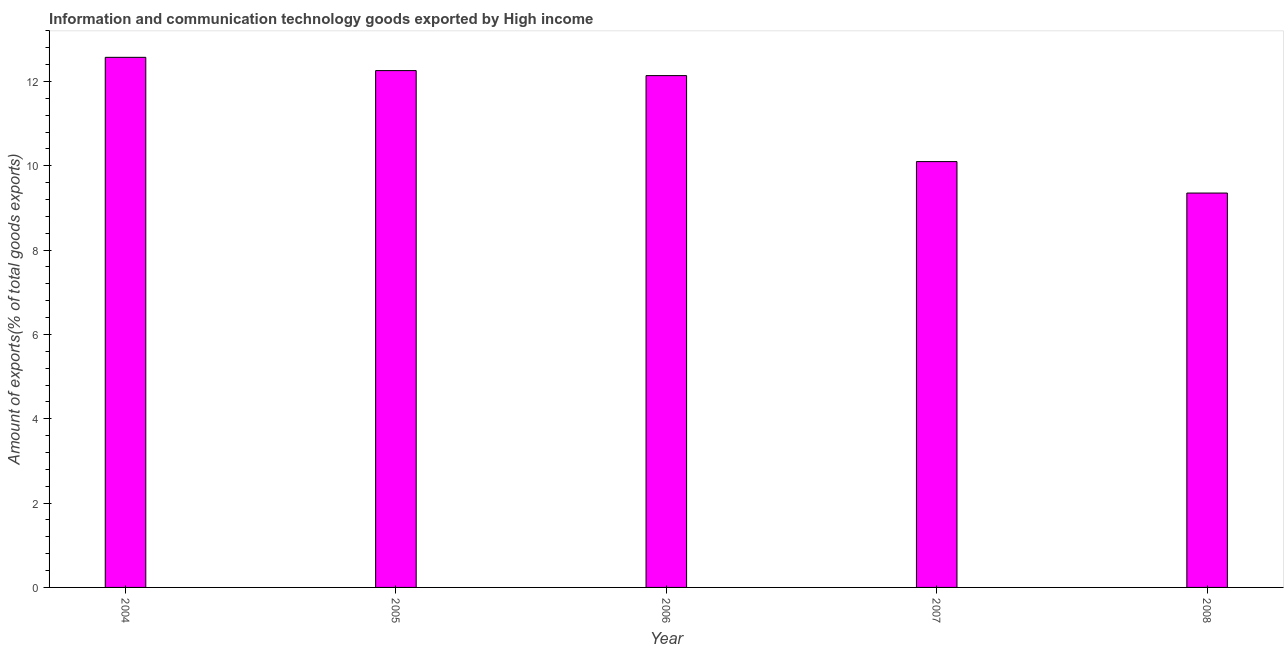Does the graph contain any zero values?
Offer a terse response. No. What is the title of the graph?
Your response must be concise. Information and communication technology goods exported by High income. What is the label or title of the X-axis?
Your answer should be compact. Year. What is the label or title of the Y-axis?
Your answer should be very brief. Amount of exports(% of total goods exports). What is the amount of ict goods exports in 2005?
Your answer should be compact. 12.26. Across all years, what is the maximum amount of ict goods exports?
Offer a very short reply. 12.57. Across all years, what is the minimum amount of ict goods exports?
Your answer should be very brief. 9.35. In which year was the amount of ict goods exports minimum?
Provide a succinct answer. 2008. What is the sum of the amount of ict goods exports?
Give a very brief answer. 56.42. What is the difference between the amount of ict goods exports in 2005 and 2006?
Offer a terse response. 0.12. What is the average amount of ict goods exports per year?
Keep it short and to the point. 11.28. What is the median amount of ict goods exports?
Your response must be concise. 12.14. In how many years, is the amount of ict goods exports greater than 7.2 %?
Your response must be concise. 5. What is the ratio of the amount of ict goods exports in 2004 to that in 2005?
Provide a short and direct response. 1.03. What is the difference between the highest and the second highest amount of ict goods exports?
Your answer should be very brief. 0.32. Is the sum of the amount of ict goods exports in 2004 and 2007 greater than the maximum amount of ict goods exports across all years?
Ensure brevity in your answer.  Yes. What is the difference between the highest and the lowest amount of ict goods exports?
Your answer should be compact. 3.22. In how many years, is the amount of ict goods exports greater than the average amount of ict goods exports taken over all years?
Make the answer very short. 3. How many bars are there?
Provide a short and direct response. 5. Are all the bars in the graph horizontal?
Provide a short and direct response. No. How many years are there in the graph?
Your answer should be very brief. 5. What is the difference between two consecutive major ticks on the Y-axis?
Your answer should be compact. 2. What is the Amount of exports(% of total goods exports) in 2004?
Provide a succinct answer. 12.57. What is the Amount of exports(% of total goods exports) of 2005?
Give a very brief answer. 12.26. What is the Amount of exports(% of total goods exports) of 2006?
Give a very brief answer. 12.14. What is the Amount of exports(% of total goods exports) of 2007?
Your answer should be very brief. 10.1. What is the Amount of exports(% of total goods exports) of 2008?
Provide a short and direct response. 9.35. What is the difference between the Amount of exports(% of total goods exports) in 2004 and 2005?
Your answer should be very brief. 0.31. What is the difference between the Amount of exports(% of total goods exports) in 2004 and 2006?
Give a very brief answer. 0.43. What is the difference between the Amount of exports(% of total goods exports) in 2004 and 2007?
Provide a short and direct response. 2.47. What is the difference between the Amount of exports(% of total goods exports) in 2004 and 2008?
Your answer should be very brief. 3.22. What is the difference between the Amount of exports(% of total goods exports) in 2005 and 2006?
Provide a short and direct response. 0.12. What is the difference between the Amount of exports(% of total goods exports) in 2005 and 2007?
Provide a short and direct response. 2.16. What is the difference between the Amount of exports(% of total goods exports) in 2005 and 2008?
Make the answer very short. 2.9. What is the difference between the Amount of exports(% of total goods exports) in 2006 and 2007?
Give a very brief answer. 2.04. What is the difference between the Amount of exports(% of total goods exports) in 2006 and 2008?
Ensure brevity in your answer.  2.79. What is the difference between the Amount of exports(% of total goods exports) in 2007 and 2008?
Your answer should be very brief. 0.75. What is the ratio of the Amount of exports(% of total goods exports) in 2004 to that in 2005?
Your answer should be compact. 1.03. What is the ratio of the Amount of exports(% of total goods exports) in 2004 to that in 2006?
Offer a very short reply. 1.04. What is the ratio of the Amount of exports(% of total goods exports) in 2004 to that in 2007?
Make the answer very short. 1.25. What is the ratio of the Amount of exports(% of total goods exports) in 2004 to that in 2008?
Make the answer very short. 1.34. What is the ratio of the Amount of exports(% of total goods exports) in 2005 to that in 2006?
Your answer should be very brief. 1.01. What is the ratio of the Amount of exports(% of total goods exports) in 2005 to that in 2007?
Your answer should be compact. 1.21. What is the ratio of the Amount of exports(% of total goods exports) in 2005 to that in 2008?
Your answer should be compact. 1.31. What is the ratio of the Amount of exports(% of total goods exports) in 2006 to that in 2007?
Provide a succinct answer. 1.2. What is the ratio of the Amount of exports(% of total goods exports) in 2006 to that in 2008?
Provide a succinct answer. 1.3. What is the ratio of the Amount of exports(% of total goods exports) in 2007 to that in 2008?
Make the answer very short. 1.08. 